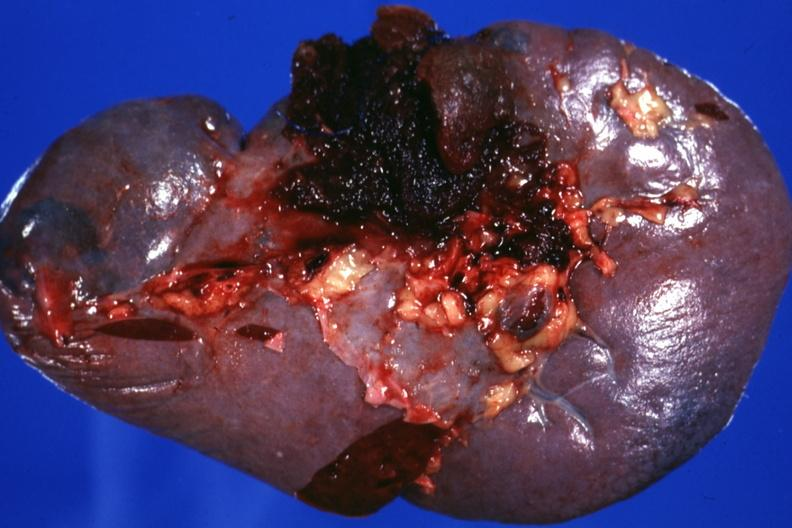what is present?
Answer the question using a single word or phrase. Spleen 